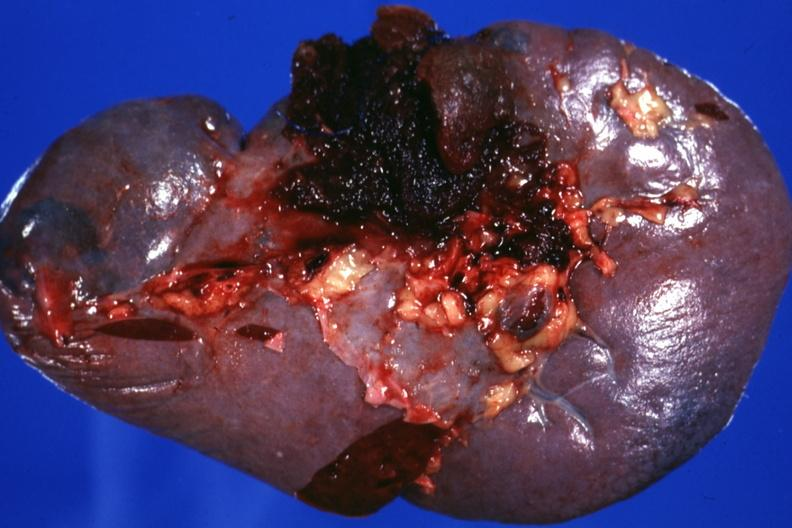what is present?
Answer the question using a single word or phrase. Spleen 